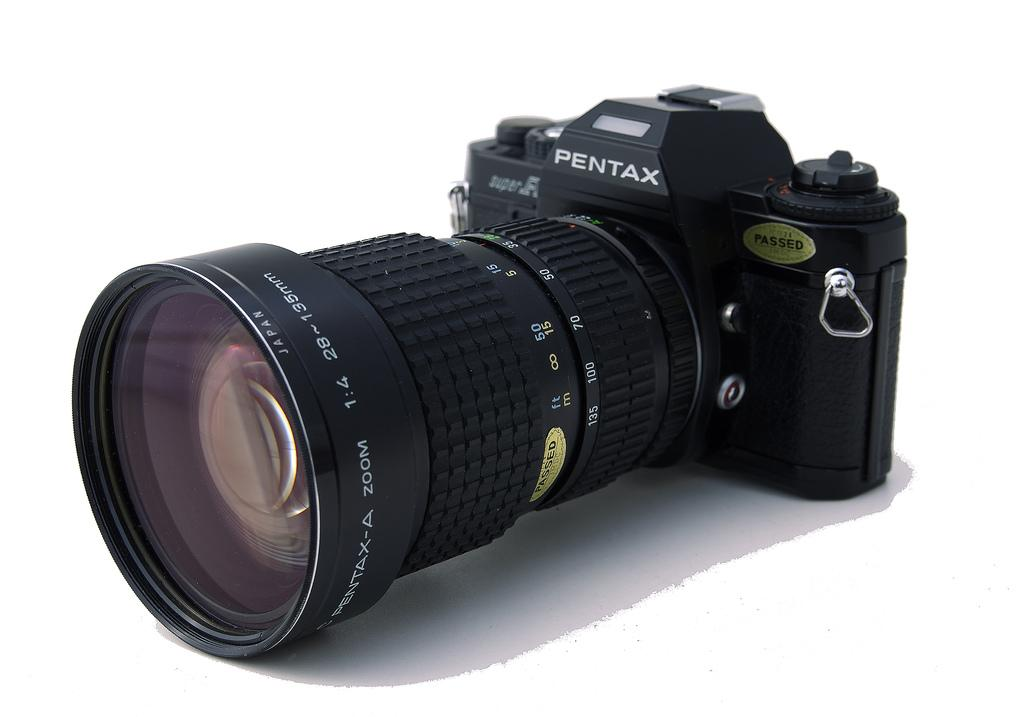What object is the main focus of the image? There is a camera in the image. What part of the camera is specifically mentioned in the facts? The camera has a lens. What type of guide is shown holding a tray with stew in the image? There is no guide, tray, or stew present in the image; it only features a camera with a lens. 